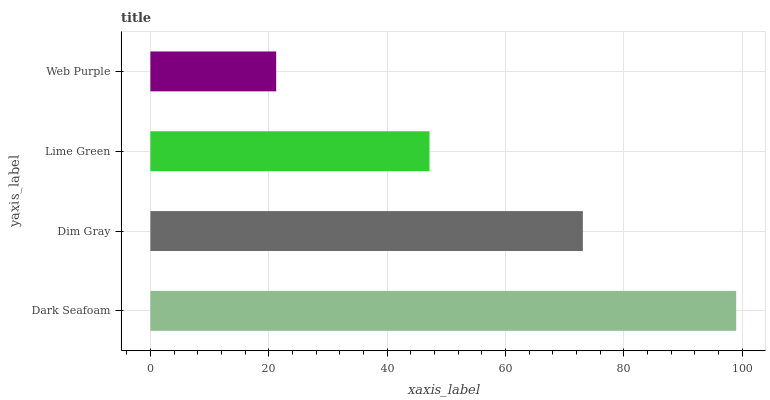Is Web Purple the minimum?
Answer yes or no. Yes. Is Dark Seafoam the maximum?
Answer yes or no. Yes. Is Dim Gray the minimum?
Answer yes or no. No. Is Dim Gray the maximum?
Answer yes or no. No. Is Dark Seafoam greater than Dim Gray?
Answer yes or no. Yes. Is Dim Gray less than Dark Seafoam?
Answer yes or no. Yes. Is Dim Gray greater than Dark Seafoam?
Answer yes or no. No. Is Dark Seafoam less than Dim Gray?
Answer yes or no. No. Is Dim Gray the high median?
Answer yes or no. Yes. Is Lime Green the low median?
Answer yes or no. Yes. Is Web Purple the high median?
Answer yes or no. No. Is Web Purple the low median?
Answer yes or no. No. 